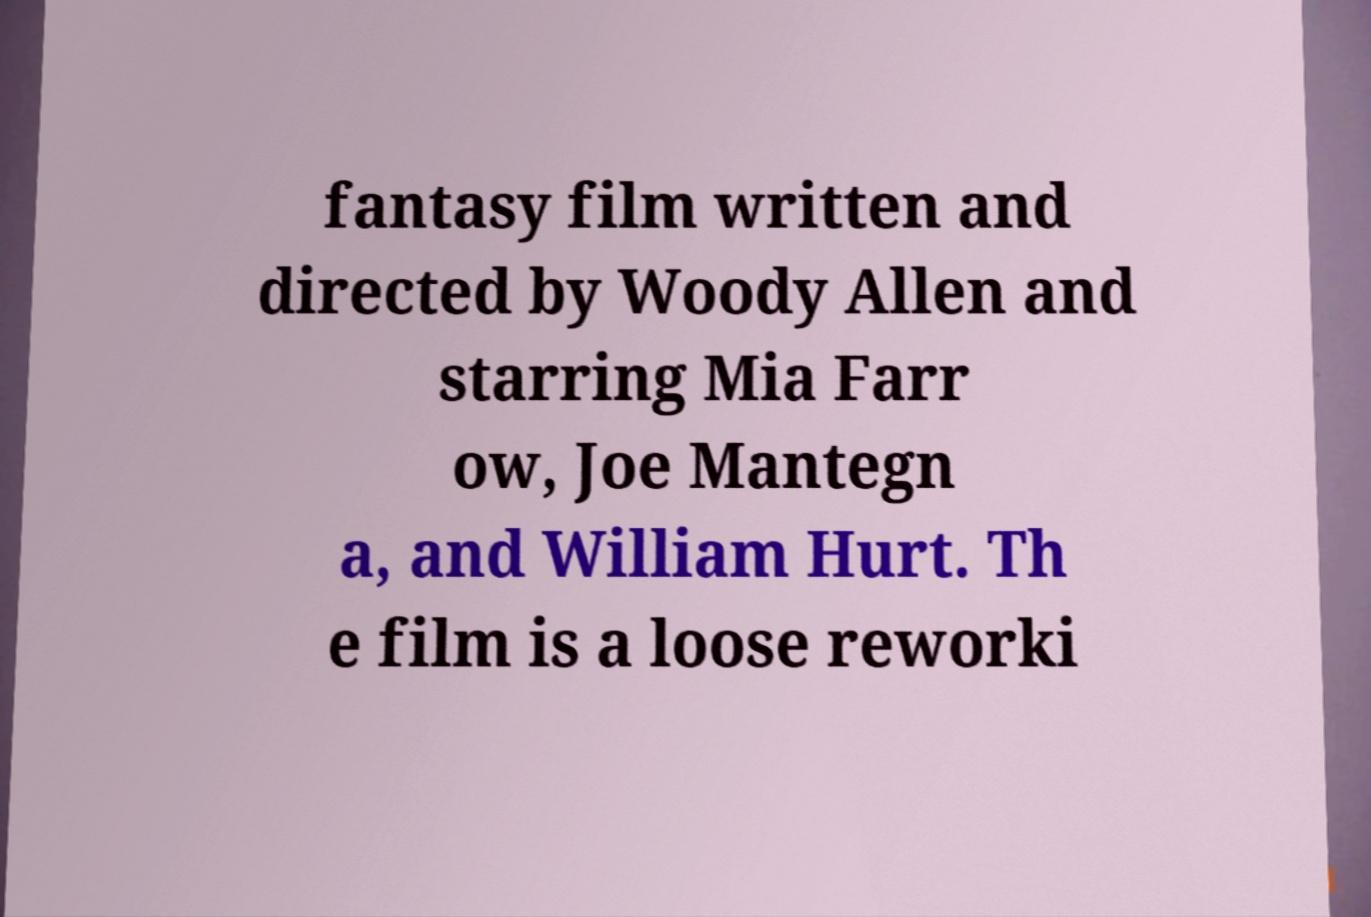Can you accurately transcribe the text from the provided image for me? fantasy film written and directed by Woody Allen and starring Mia Farr ow, Joe Mantegn a, and William Hurt. Th e film is a loose reworki 